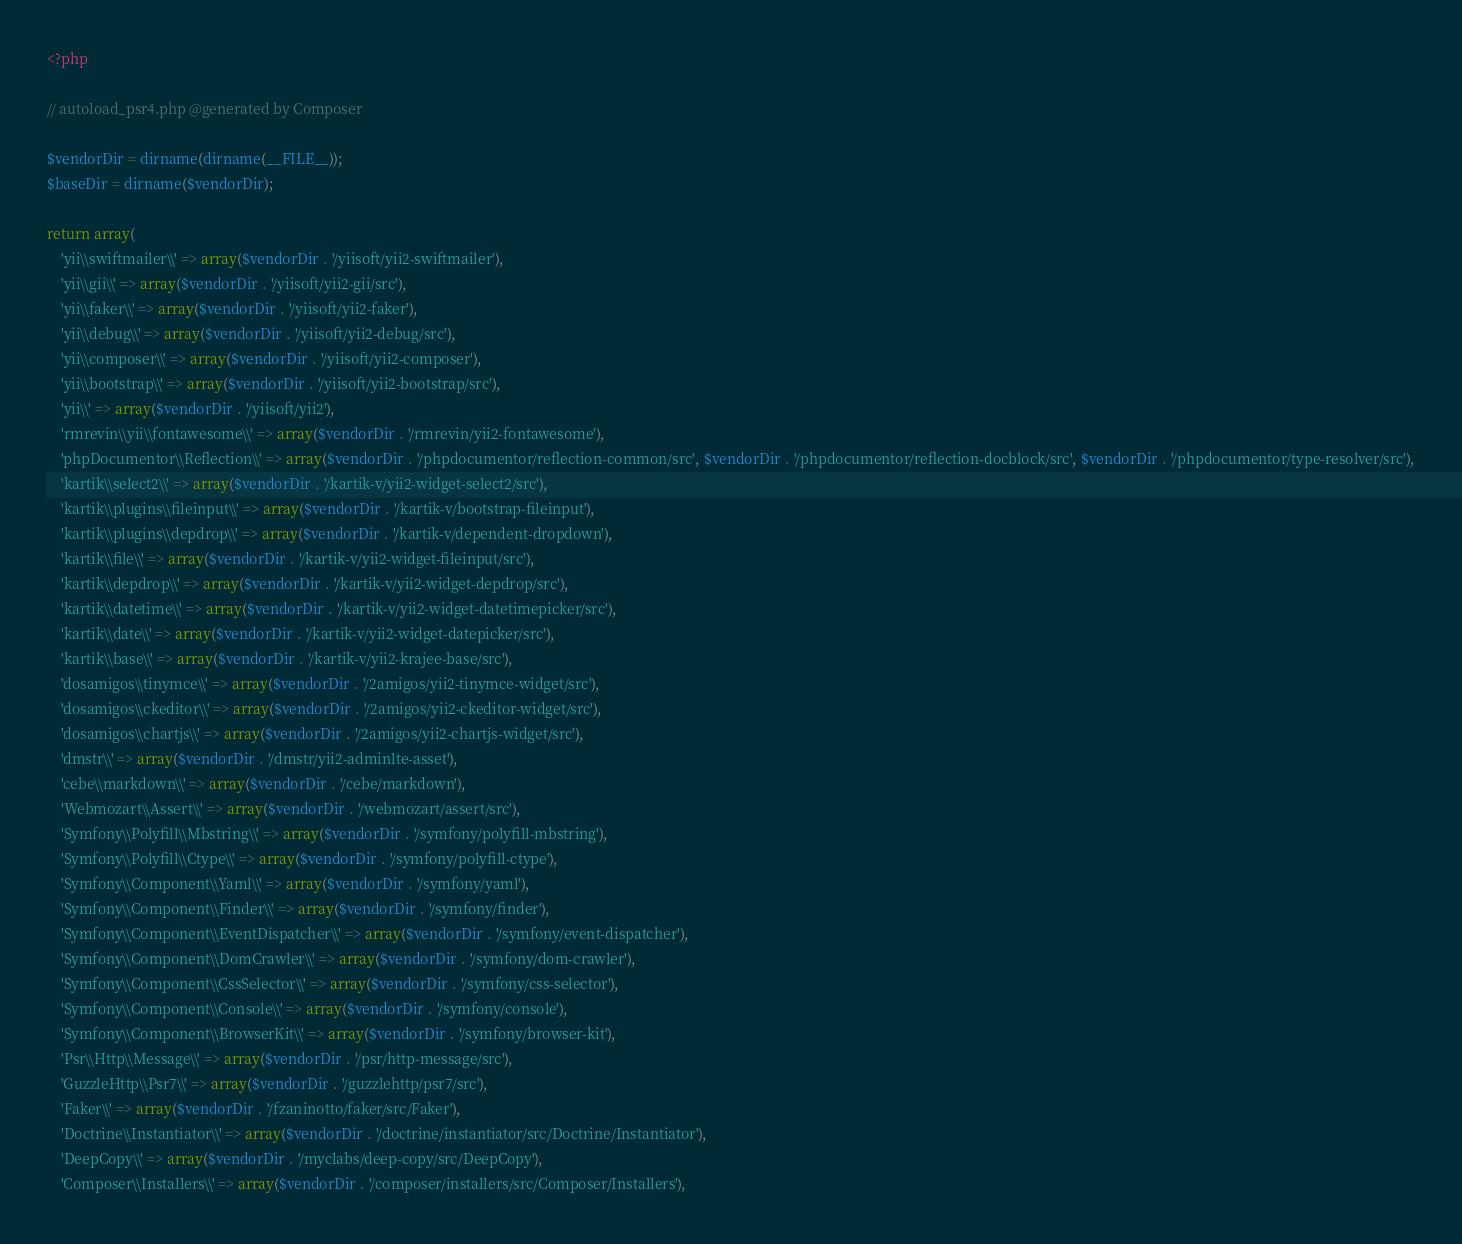<code> <loc_0><loc_0><loc_500><loc_500><_PHP_><?php

// autoload_psr4.php @generated by Composer

$vendorDir = dirname(dirname(__FILE__));
$baseDir = dirname($vendorDir);

return array(
    'yii\\swiftmailer\\' => array($vendorDir . '/yiisoft/yii2-swiftmailer'),
    'yii\\gii\\' => array($vendorDir . '/yiisoft/yii2-gii/src'),
    'yii\\faker\\' => array($vendorDir . '/yiisoft/yii2-faker'),
    'yii\\debug\\' => array($vendorDir . '/yiisoft/yii2-debug/src'),
    'yii\\composer\\' => array($vendorDir . '/yiisoft/yii2-composer'),
    'yii\\bootstrap\\' => array($vendorDir . '/yiisoft/yii2-bootstrap/src'),
    'yii\\' => array($vendorDir . '/yiisoft/yii2'),
    'rmrevin\\yii\\fontawesome\\' => array($vendorDir . '/rmrevin/yii2-fontawesome'),
    'phpDocumentor\\Reflection\\' => array($vendorDir . '/phpdocumentor/reflection-common/src', $vendorDir . '/phpdocumentor/reflection-docblock/src', $vendorDir . '/phpdocumentor/type-resolver/src'),
    'kartik\\select2\\' => array($vendorDir . '/kartik-v/yii2-widget-select2/src'),
    'kartik\\plugins\\fileinput\\' => array($vendorDir . '/kartik-v/bootstrap-fileinput'),
    'kartik\\plugins\\depdrop\\' => array($vendorDir . '/kartik-v/dependent-dropdown'),
    'kartik\\file\\' => array($vendorDir . '/kartik-v/yii2-widget-fileinput/src'),
    'kartik\\depdrop\\' => array($vendorDir . '/kartik-v/yii2-widget-depdrop/src'),
    'kartik\\datetime\\' => array($vendorDir . '/kartik-v/yii2-widget-datetimepicker/src'),
    'kartik\\date\\' => array($vendorDir . '/kartik-v/yii2-widget-datepicker/src'),
    'kartik\\base\\' => array($vendorDir . '/kartik-v/yii2-krajee-base/src'),
    'dosamigos\\tinymce\\' => array($vendorDir . '/2amigos/yii2-tinymce-widget/src'),
    'dosamigos\\ckeditor\\' => array($vendorDir . '/2amigos/yii2-ckeditor-widget/src'),
    'dosamigos\\chartjs\\' => array($vendorDir . '/2amigos/yii2-chartjs-widget/src'),
    'dmstr\\' => array($vendorDir . '/dmstr/yii2-adminlte-asset'),
    'cebe\\markdown\\' => array($vendorDir . '/cebe/markdown'),
    'Webmozart\\Assert\\' => array($vendorDir . '/webmozart/assert/src'),
    'Symfony\\Polyfill\\Mbstring\\' => array($vendorDir . '/symfony/polyfill-mbstring'),
    'Symfony\\Polyfill\\Ctype\\' => array($vendorDir . '/symfony/polyfill-ctype'),
    'Symfony\\Component\\Yaml\\' => array($vendorDir . '/symfony/yaml'),
    'Symfony\\Component\\Finder\\' => array($vendorDir . '/symfony/finder'),
    'Symfony\\Component\\EventDispatcher\\' => array($vendorDir . '/symfony/event-dispatcher'),
    'Symfony\\Component\\DomCrawler\\' => array($vendorDir . '/symfony/dom-crawler'),
    'Symfony\\Component\\CssSelector\\' => array($vendorDir . '/symfony/css-selector'),
    'Symfony\\Component\\Console\\' => array($vendorDir . '/symfony/console'),
    'Symfony\\Component\\BrowserKit\\' => array($vendorDir . '/symfony/browser-kit'),
    'Psr\\Http\\Message\\' => array($vendorDir . '/psr/http-message/src'),
    'GuzzleHttp\\Psr7\\' => array($vendorDir . '/guzzlehttp/psr7/src'),
    'Faker\\' => array($vendorDir . '/fzaninotto/faker/src/Faker'),
    'Doctrine\\Instantiator\\' => array($vendorDir . '/doctrine/instantiator/src/Doctrine/Instantiator'),
    'DeepCopy\\' => array($vendorDir . '/myclabs/deep-copy/src/DeepCopy'),
    'Composer\\Installers\\' => array($vendorDir . '/composer/installers/src/Composer/Installers'),</code> 